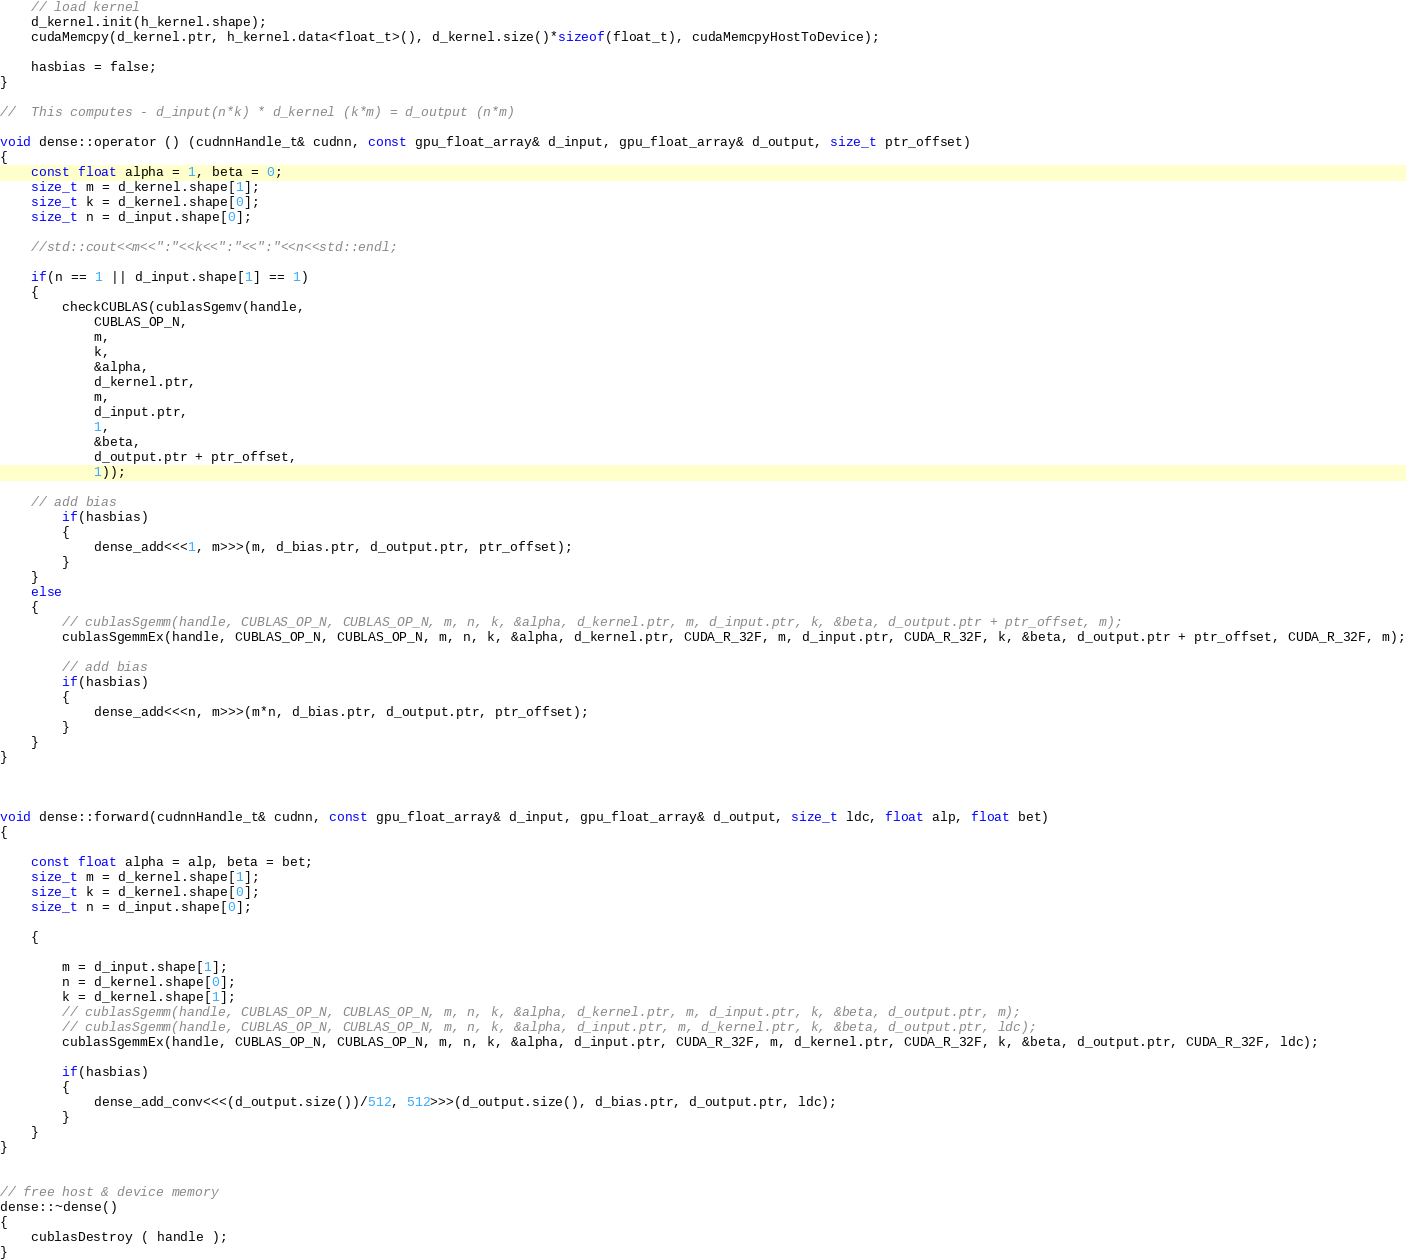<code> <loc_0><loc_0><loc_500><loc_500><_Cuda_>
	// load kernel
	d_kernel.init(h_kernel.shape);
	cudaMemcpy(d_kernel.ptr, h_kernel.data<float_t>(), d_kernel.size()*sizeof(float_t), cudaMemcpyHostToDevice);

	hasbias = false;
}

//  This computes - d_input(n*k) * d_kernel (k*m) = d_output (n*m)

void dense::operator () (cudnnHandle_t& cudnn, const gpu_float_array& d_input, gpu_float_array& d_output, size_t ptr_offset)
{
	const float alpha = 1, beta = 0;
	size_t m = d_kernel.shape[1]; 
	size_t k = d_kernel.shape[0];
	size_t n = d_input.shape[0];

	//std::cout<<m<<":"<<k<<":"<<":"<<n<<std::endl;

	if(n == 1 || d_input.shape[1] == 1)
	{
		checkCUBLAS(cublasSgemv(handle,
			CUBLAS_OP_N,
			m,
			k,
			&alpha,
			d_kernel.ptr,
			m,
			d_input.ptr,
			1,
			&beta,
			d_output.ptr + ptr_offset,
			1));

	// add bias	
		if(hasbias)
		{
			dense_add<<<1, m>>>(m, d_bias.ptr, d_output.ptr, ptr_offset);
		}
	}
	else
	{
		// cublasSgemm(handle, CUBLAS_OP_N, CUBLAS_OP_N, m, n, k, &alpha, d_kernel.ptr, m, d_input.ptr, k, &beta, d_output.ptr + ptr_offset, m);
		cublasSgemmEx(handle, CUBLAS_OP_N, CUBLAS_OP_N, m, n, k, &alpha, d_kernel.ptr, CUDA_R_32F, m, d_input.ptr, CUDA_R_32F, k, &beta, d_output.ptr + ptr_offset, CUDA_R_32F, m);

		// add bias	
		if(hasbias)
		{
			dense_add<<<n, m>>>(m*n, d_bias.ptr, d_output.ptr, ptr_offset);
		}
	}
}



void dense::forward(cudnnHandle_t& cudnn, const gpu_float_array& d_input, gpu_float_array& d_output, size_t ldc, float alp, float bet)
{

	const float alpha = alp, beta = bet;
	size_t m = d_kernel.shape[1]; 
	size_t k = d_kernel.shape[0];
	size_t n = d_input.shape[0];

	{

		m = d_input.shape[1];
		n = d_kernel.shape[0];
		k = d_kernel.shape[1];
		// cublasSgemm(handle, CUBLAS_OP_N, CUBLAS_OP_N, m, n, k, &alpha, d_kernel.ptr, m, d_input.ptr, k, &beta, d_output.ptr, m);
		// cublasSgemm(handle, CUBLAS_OP_N, CUBLAS_OP_N, m, n, k, &alpha, d_input.ptr, m, d_kernel.ptr, k, &beta, d_output.ptr, ldc);
		cublasSgemmEx(handle, CUBLAS_OP_N, CUBLAS_OP_N, m, n, k, &alpha, d_input.ptr, CUDA_R_32F, m, d_kernel.ptr, CUDA_R_32F, k, &beta, d_output.ptr, CUDA_R_32F, ldc);

		if(hasbias)
		{	
			dense_add_conv<<<(d_output.size())/512, 512>>>(d_output.size(), d_bias.ptr, d_output.ptr, ldc);
		}
	}
}


// free host & device memory
dense::~dense()
{
	cublasDestroy ( handle );
}
</code> 